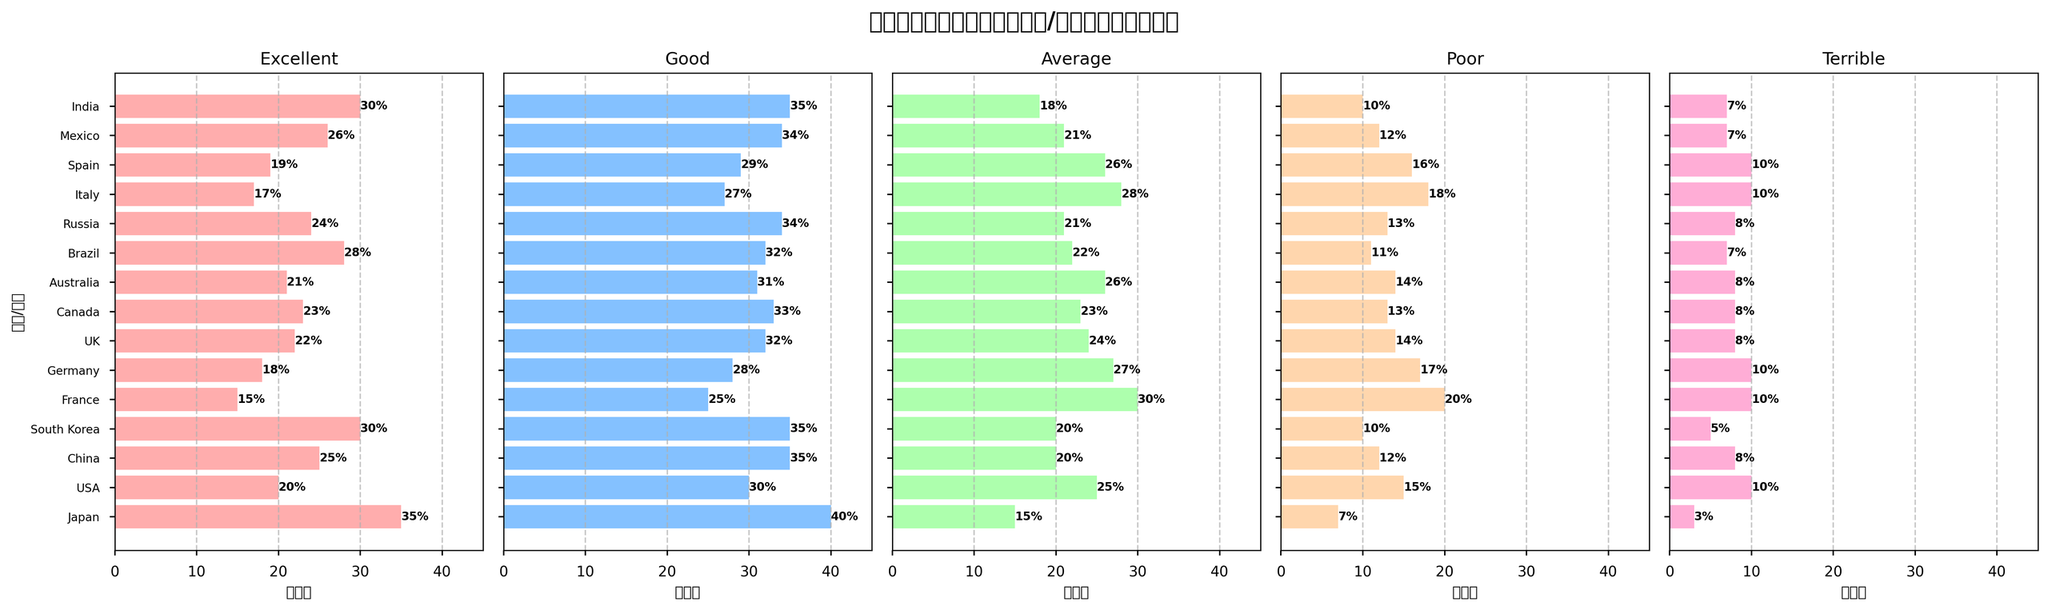What country had the highest percentage of "Excellent" ratings? By looking at the "Excellent" subplot, identify the height of the bars corresponding to each country and find the highest one. Japan has the highest bar with a percentage of 35%.
Answer: Japan Which two countries have the closest percentage of "Terrible" ratings? Compare the bars in the "Terrible" subplot to see which two countries have bars of approximately the same height. Japan and India both have bars at the 7% mark, which is the closest.
Answer: Japan and India What is the average percentage of "Good" ratings given by USA, China, and Japan? Add the percentages of "Good" ratings from these three countries: USA (30%), China (35%), and Japan (40%). Then divide by 3 to get the average. (30 + 35 + 40) / 3 = 35%
Answer: 35% Is the distribution of ratings more positive (Excellent + Good) or negative (Poor + Terrible) in the UK? Add the percentages of "Excellent" and "Good" (22% + 32% = 54%) and compare with the sum of "Poor" and "Terrible" (14% + 8% = 22%). 54% is greater than 22%, so the distribution is more positive.
Answer: Positive Which country has the highest percentage of "Poor" ratings? Check the heights of the bars in the "Poor" subplot to find the highest one. France has the highest bar at 20%.
Answer: France Which country has the lowest percentage of "Average" ratings? Identify the shortest bar in the "Average" subplot. Japan has the lowest percentage with a 15% rating.
Answer: Japan How much greater is the percentage of "Excellent" ratings in Brazil compared to Italy? Find the percentages for Brazil (28%) and Italy (17%). Calculate the difference: 28 - 17 = 11%.
Answer: 11% What is the sum of "Good" and "Poor" percentages in South Korea? Add the percentages of "Good" (35%) and "Poor" (10%) ratings from South Korea: 35 + 10 = 45%.
Answer: 45% How does the percentage of "Terrible" ratings in Canada compare to the percentage of "Terrible" ratings in Russia? Compare the bars in the "Terrible" subplot for Canada and Russia. Both have the same percentage of "Terrible" ratings at 8%.
Answer: 0% (equal) 